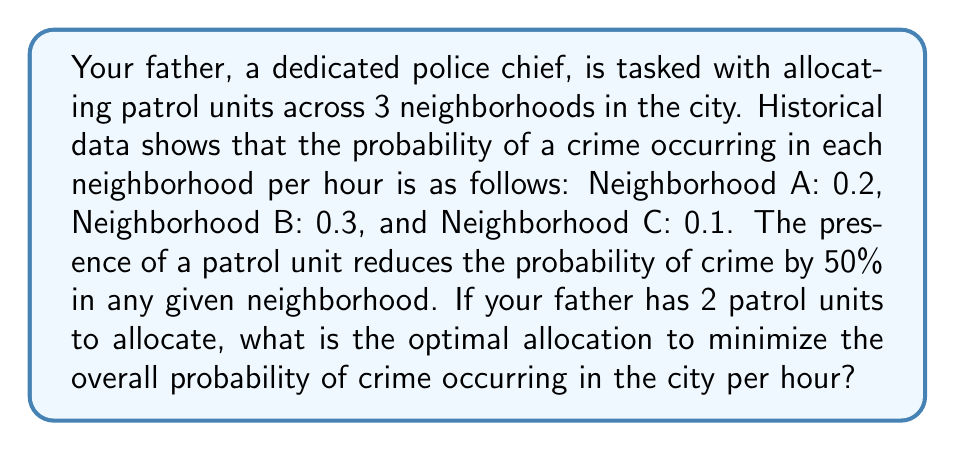Can you answer this question? Let's approach this step-by-step:

1) First, let's define variables:
   Let $x_A$, $x_B$, and $x_C$ be the number of patrol units allocated to neighborhoods A, B, and C respectively.

2) We know that:
   $x_A + x_B + x_C = 2$ (total available units)
   $x_A, x_B, x_C \in \{0, 1, 2\}$ (units are whole numbers)

3) The probability of crime in each neighborhood with $x$ units present is:
   $P(\text{crime}) = \text{Original probability} \times (0.5)^x$

4) So, the total probability of crime occurring in the city is:
   $P(\text{total}) = 0.2 \times (0.5)^{x_A} + 0.3 \times (0.5)^{x_B} + 0.1 \times (0.5)^{x_C}$

5) We need to minimize this function. Let's calculate it for all possible allocations:

   $(x_A, x_B, x_C) = (2, 0, 0): P = 0.2 \times (0.5)^2 + 0.3 + 0.1 = 0.45$
   $(x_A, x_B, x_C) = (0, 2, 0): P = 0.2 + 0.3 \times (0.5)^2 + 0.1 = 0.375$
   $(x_A, x_B, x_C) = (0, 0, 2): P = 0.2 + 0.3 + 0.1 \times (0.5)^2 = 0.525$
   $(x_A, x_B, x_C) = (1, 1, 0): P = 0.2 \times 0.5 + 0.3 \times 0.5 + 0.1 = 0.35$
   $(x_A, x_B, x_C) = (1, 0, 1): P = 0.2 \times 0.5 + 0.3 + 0.1 \times 0.5 = 0.45$
   $(x_A, x_B, x_C) = (0, 1, 1): P = 0.2 + 0.3 \times 0.5 + 0.1 \times 0.5 = 0.4$

6) The minimum probability is 0.35, which occurs when one unit is allocated to Neighborhood A and one to Neighborhood B.
Answer: The optimal allocation is to assign one patrol unit to Neighborhood A and one to Neighborhood B, resulting in a minimum overall probability of crime of 0.35 per hour. 